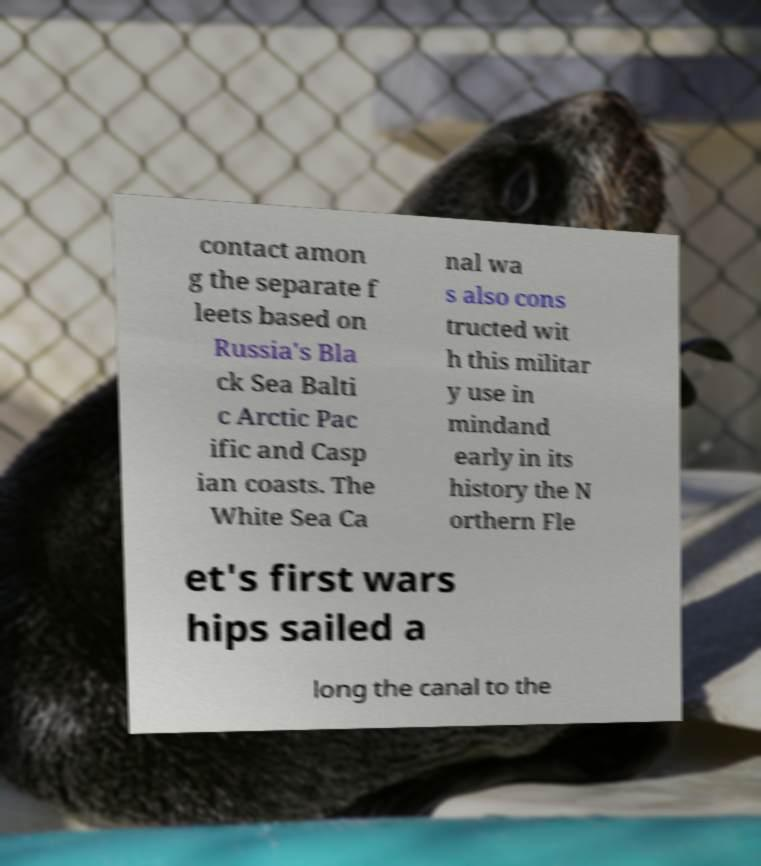Can you accurately transcribe the text from the provided image for me? contact amon g the separate f leets based on Russia's Bla ck Sea Balti c Arctic Pac ific and Casp ian coasts. The White Sea Ca nal wa s also cons tructed wit h this militar y use in mindand early in its history the N orthern Fle et's first wars hips sailed a long the canal to the 